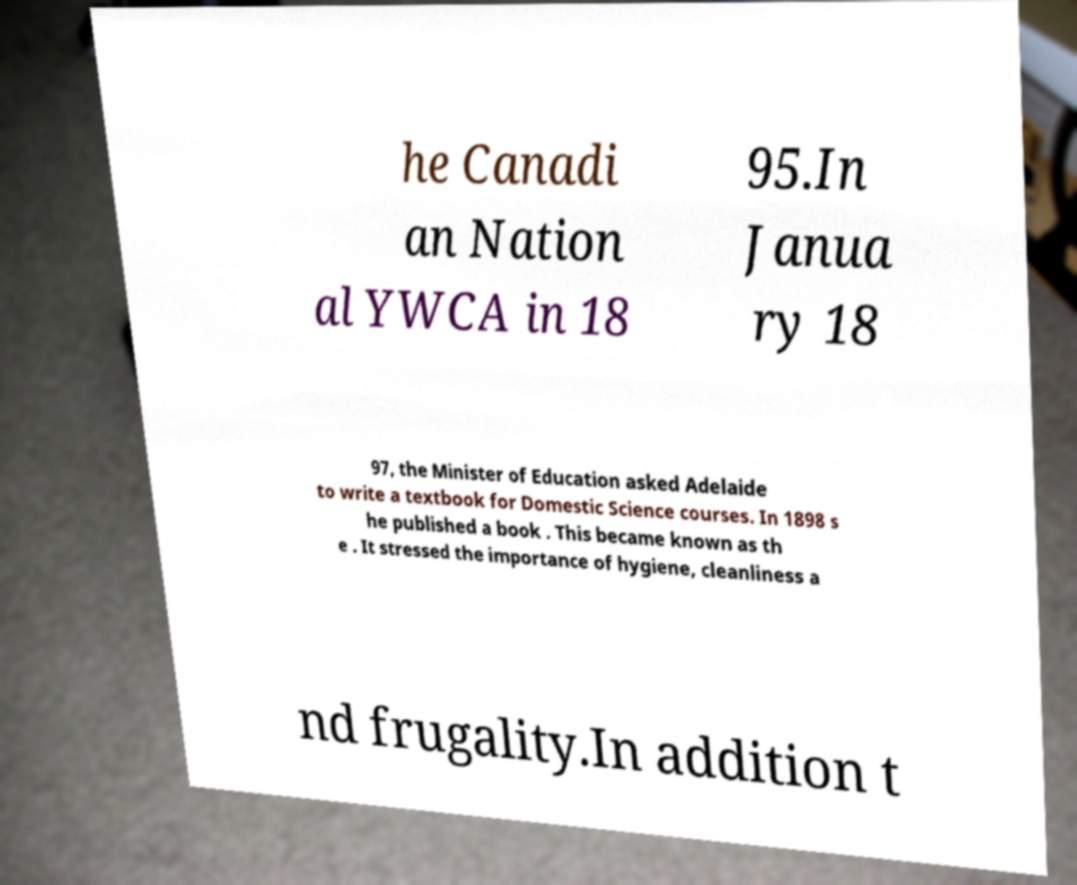Please read and relay the text visible in this image. What does it say? he Canadi an Nation al YWCA in 18 95.In Janua ry 18 97, the Minister of Education asked Adelaide to write a textbook for Domestic Science courses. In 1898 s he published a book . This became known as th e . It stressed the importance of hygiene, cleanliness a nd frugality.In addition t 